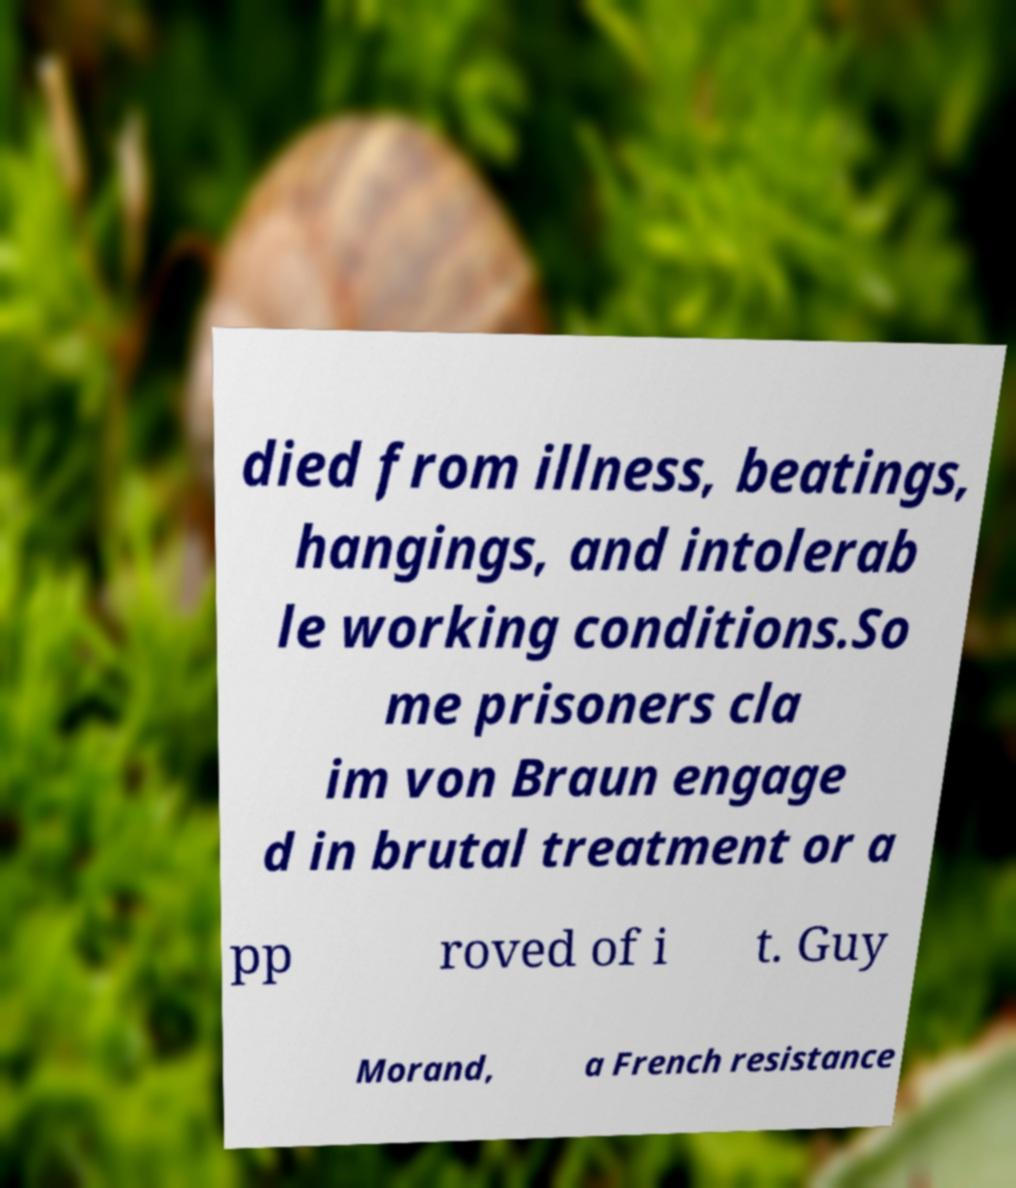I need the written content from this picture converted into text. Can you do that? died from illness, beatings, hangings, and intolerab le working conditions.So me prisoners cla im von Braun engage d in brutal treatment or a pp roved of i t. Guy Morand, a French resistance 